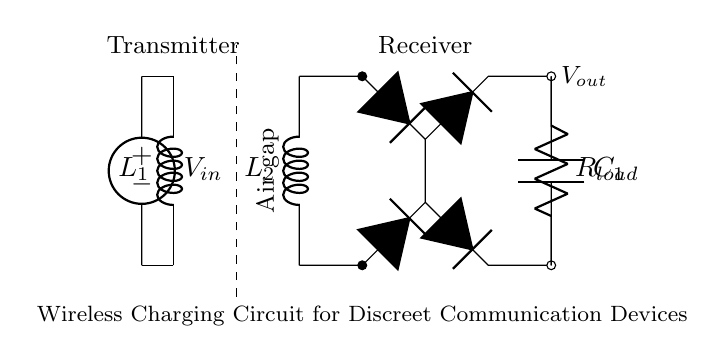What type of circuit is this? This is a wireless charging circuit, as indicated by the wireless charging coils for transmitting and receiving power.
Answer: wireless charging What is the function of the inductor labeled L1? The inductor L1 serves as the transmitting coil, generating a magnetic field used for transferring energy wirelessly to the receiver coil (L2).
Answer: transmitting coil What is the purpose of the rectifier bridge? The rectifier bridge converts alternating current (AC) from the receiver coil into direct current (DC) for the load.
Answer: convert AC to DC What is the voltage supply in this circuit? The voltage supply is labeled as V_in, but the specific voltage value is not provided in the circuit.
Answer: V_in How many capacitors are present in the circuit? There is one capacitor labeled C1 used for smoothing the output voltage from the rectifier.
Answer: one Why is there an air gap between the transmitter and receiver coils? The air gap is necessary for wireless power transfer, allowing the magnetic field produced by the transmitter coil to induce voltage in the receiver coil without direct contact.
Answer: necessary for power transfer What component is used to load the circuit? The load resistor labeled R_load is used to take energy from the circuit for usage in the connected device.
Answer: load resistor 